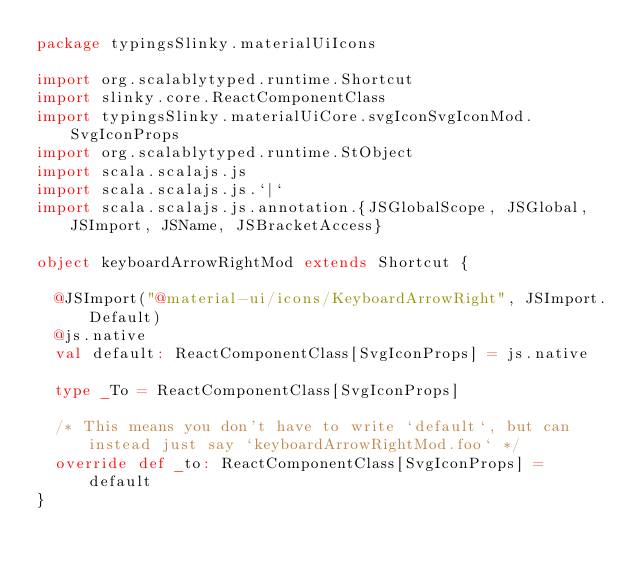<code> <loc_0><loc_0><loc_500><loc_500><_Scala_>package typingsSlinky.materialUiIcons

import org.scalablytyped.runtime.Shortcut
import slinky.core.ReactComponentClass
import typingsSlinky.materialUiCore.svgIconSvgIconMod.SvgIconProps
import org.scalablytyped.runtime.StObject
import scala.scalajs.js
import scala.scalajs.js.`|`
import scala.scalajs.js.annotation.{JSGlobalScope, JSGlobal, JSImport, JSName, JSBracketAccess}

object keyboardArrowRightMod extends Shortcut {
  
  @JSImport("@material-ui/icons/KeyboardArrowRight", JSImport.Default)
  @js.native
  val default: ReactComponentClass[SvgIconProps] = js.native
  
  type _To = ReactComponentClass[SvgIconProps]
  
  /* This means you don't have to write `default`, but can instead just say `keyboardArrowRightMod.foo` */
  override def _to: ReactComponentClass[SvgIconProps] = default
}
</code> 